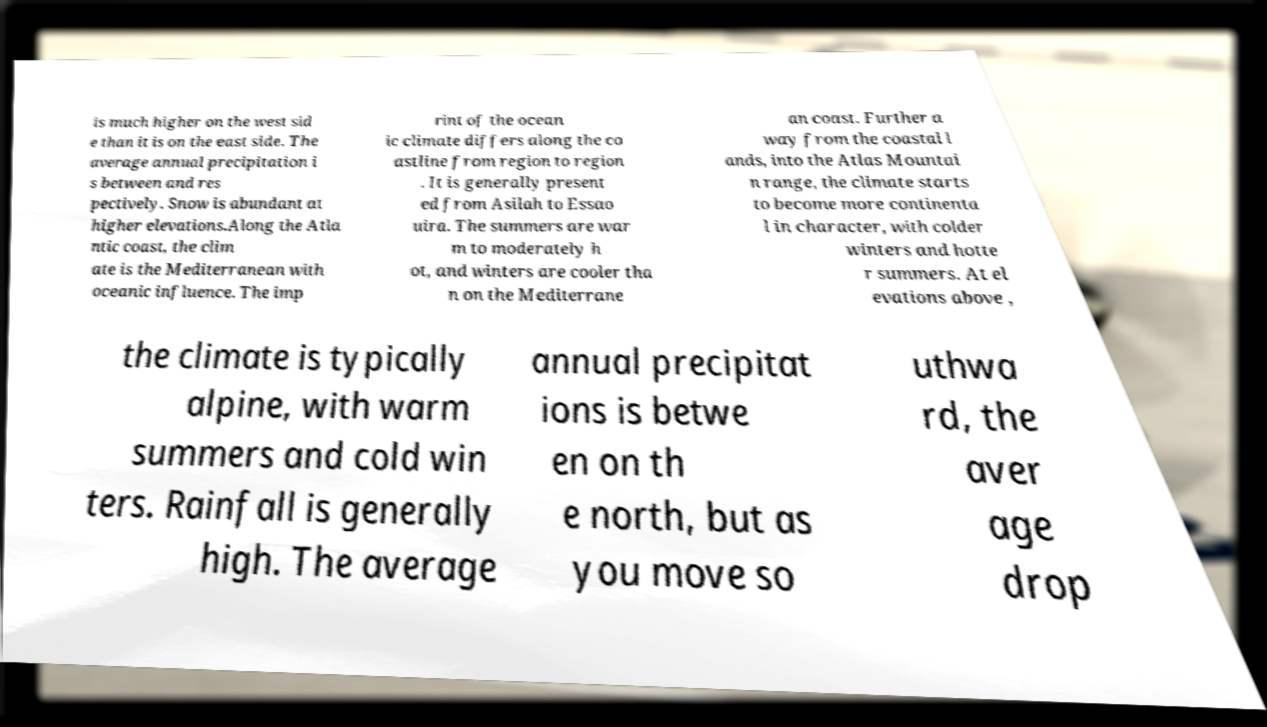Please identify and transcribe the text found in this image. is much higher on the west sid e than it is on the east side. The average annual precipitation i s between and res pectively. Snow is abundant at higher elevations.Along the Atla ntic coast, the clim ate is the Mediterranean with oceanic influence. The imp rint of the ocean ic climate differs along the co astline from region to region . It is generally present ed from Asilah to Essao uira. The summers are war m to moderately h ot, and winters are cooler tha n on the Mediterrane an coast. Further a way from the coastal l ands, into the Atlas Mountai n range, the climate starts to become more continenta l in character, with colder winters and hotte r summers. At el evations above , the climate is typically alpine, with warm summers and cold win ters. Rainfall is generally high. The average annual precipitat ions is betwe en on th e north, but as you move so uthwa rd, the aver age drop 